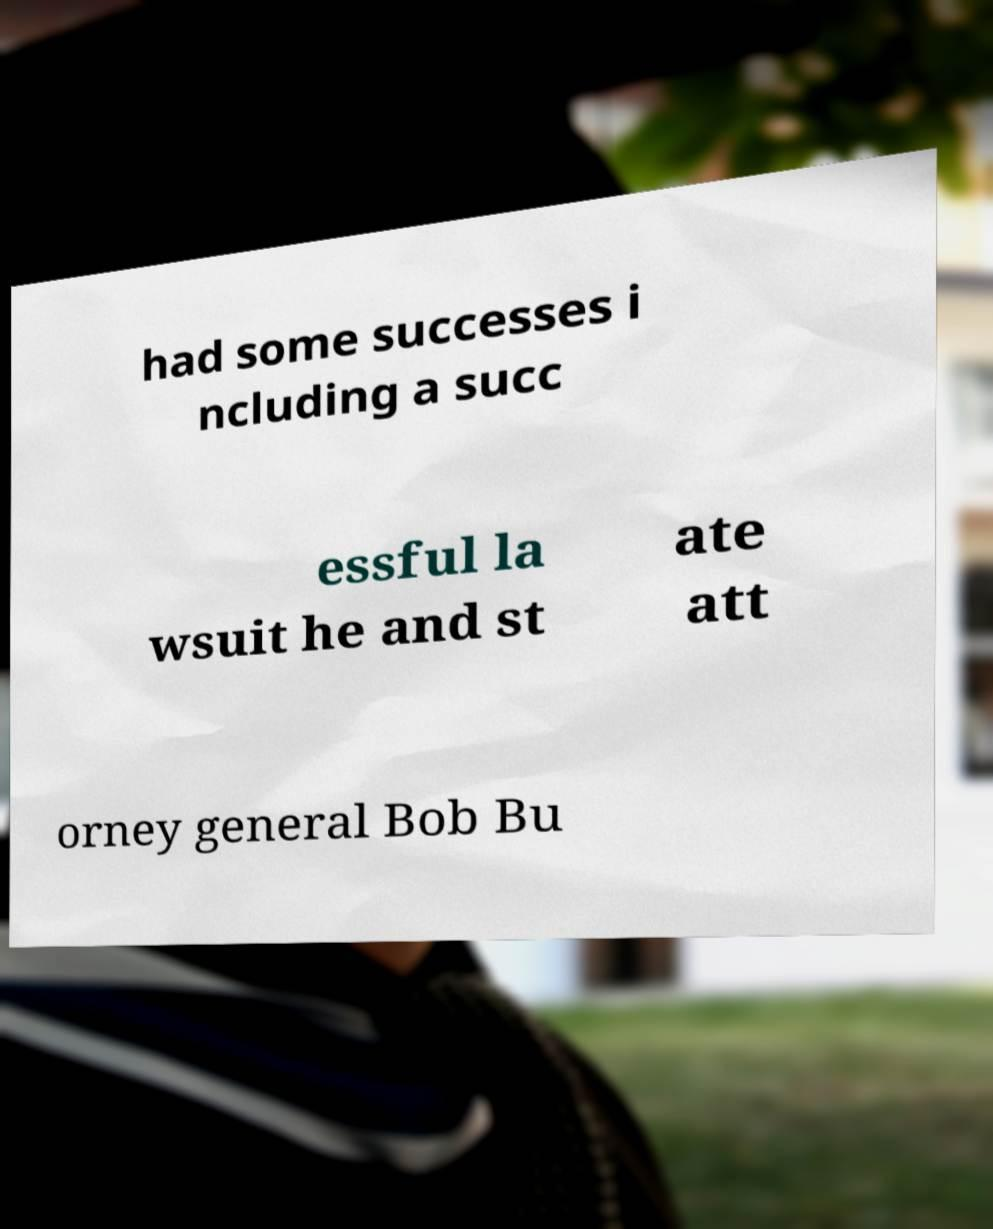There's text embedded in this image that I need extracted. Can you transcribe it verbatim? had some successes i ncluding a succ essful la wsuit he and st ate att orney general Bob Bu 